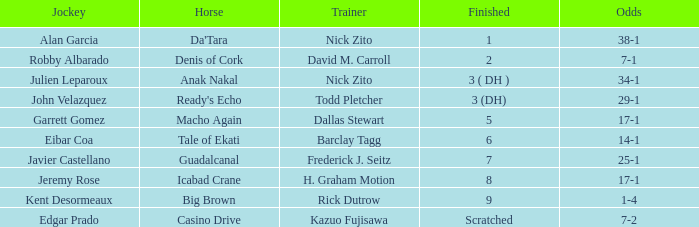Which Horse finished in 8? Icabad Crane. 